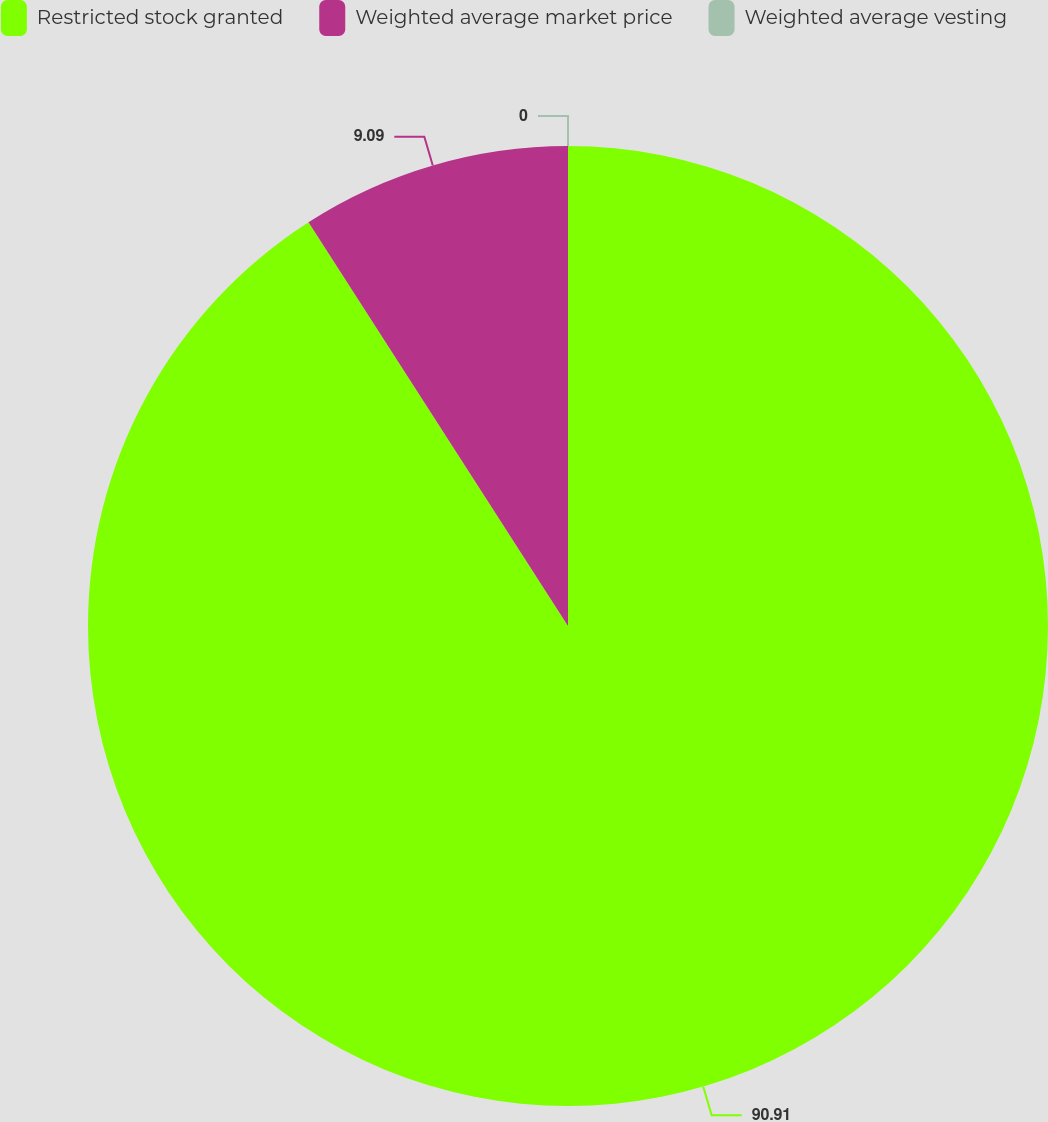<chart> <loc_0><loc_0><loc_500><loc_500><pie_chart><fcel>Restricted stock granted<fcel>Weighted average market price<fcel>Weighted average vesting<nl><fcel>90.91%<fcel>9.09%<fcel>0.0%<nl></chart> 